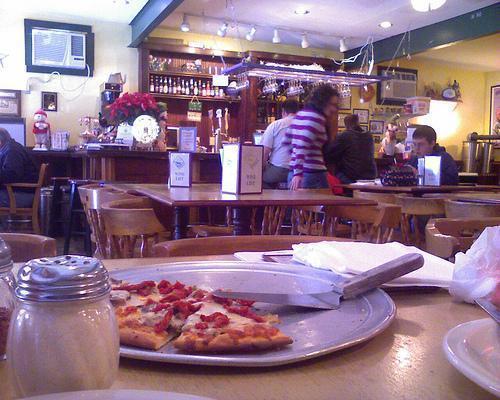What does the tool near the pizza do?
Indicate the correct response and explain using: 'Answer: answer
Rationale: rationale.'
Options: Cook pizza, destroy pizza, scoop pizza, store pizza. Answer: scoop pizza.
Rationale: The tool cuts pizza. 